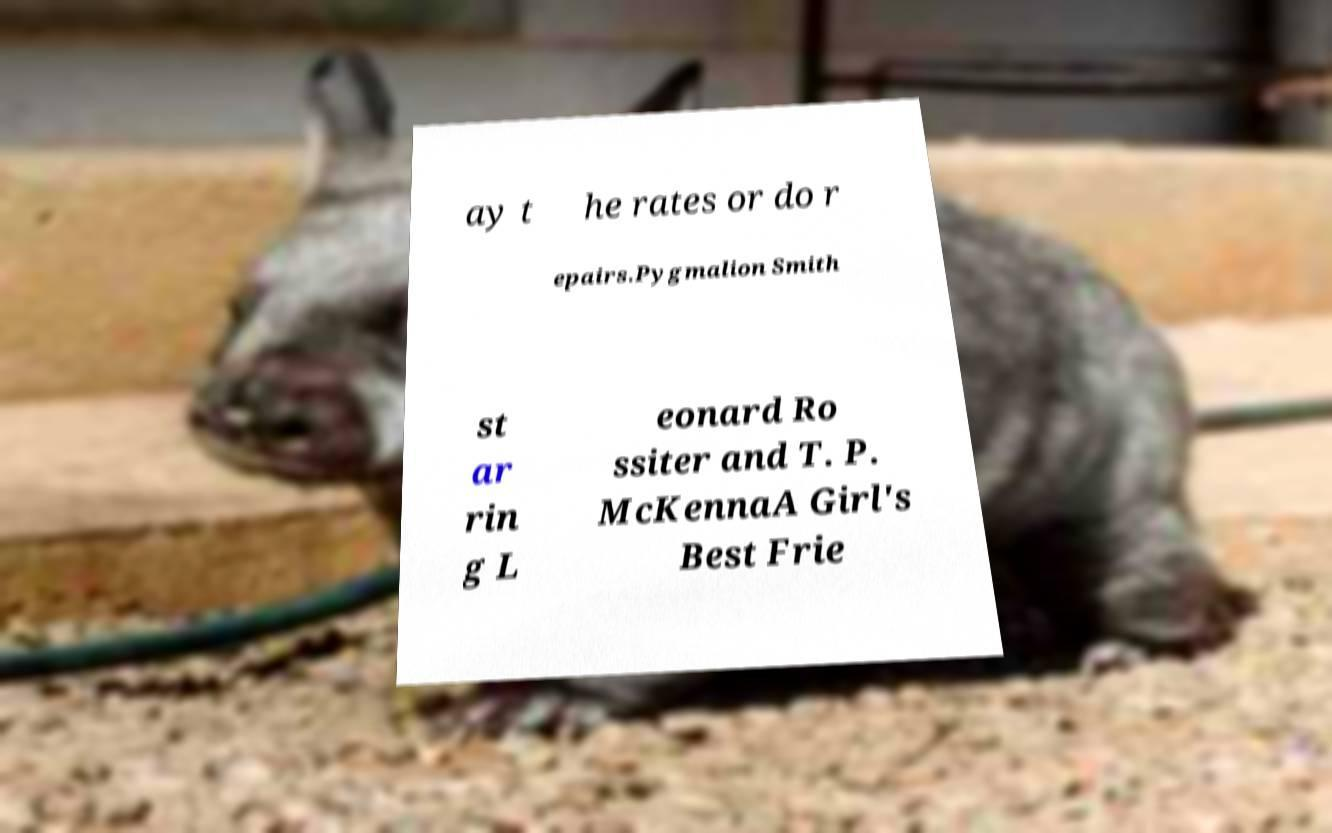Could you assist in decoding the text presented in this image and type it out clearly? ay t he rates or do r epairs.Pygmalion Smith st ar rin g L eonard Ro ssiter and T. P. McKennaA Girl's Best Frie 